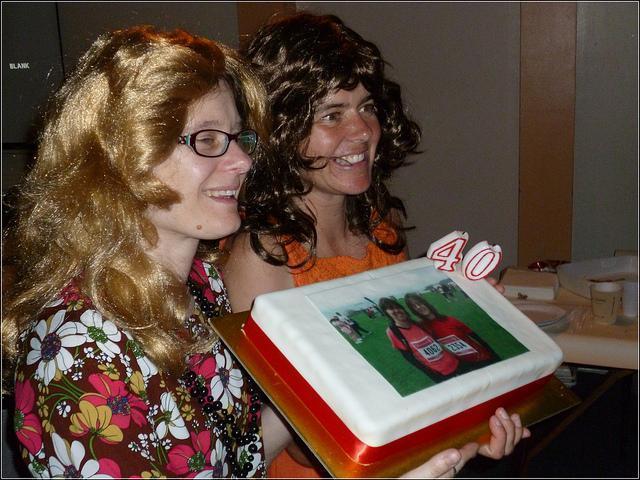How old is the birthday girl?
Answer the question by selecting the correct answer among the 4 following choices and explain your choice with a short sentence. The answer should be formatted with the following format: `Answer: choice
Rationale: rationale.`
Options: 30, ten, 20, 40. Answer: 40.
Rationale: The candles state "40.". 